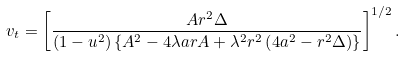<formula> <loc_0><loc_0><loc_500><loc_500>v _ { t } = \left [ \frac { A r ^ { 2 } \Delta } { \left ( 1 - u ^ { 2 } \right ) \left \{ A ^ { 2 } - 4 \lambda a r A + \lambda ^ { 2 } r ^ { 2 } \left ( 4 a ^ { 2 } - r ^ { 2 } \Delta \right ) \right \} } \right ] ^ { 1 / 2 } .</formula> 